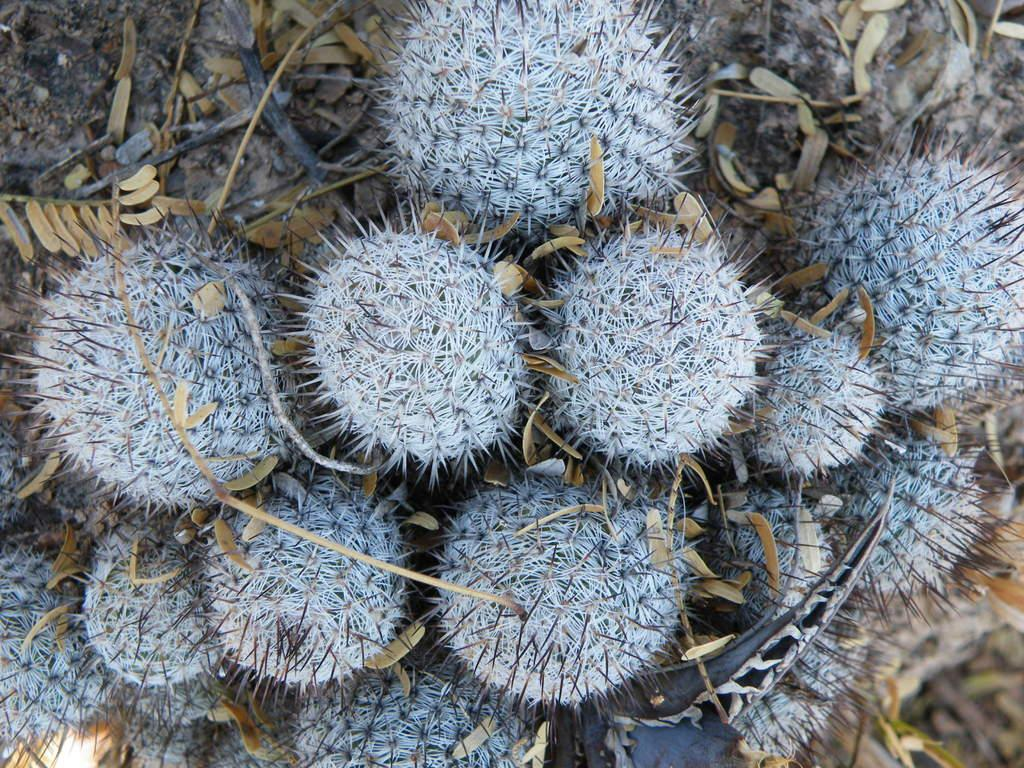What type of living organisms can be seen in the image? Plants can be seen in the image. What is a characteristic of the plants in the image? Dry leaves are present in the image. What part of the plants is visible in the image? Stems are visible in the image. How does the sock move around in the image? There is no sock present in the image. What type of sugar is visible in the image? There is no sugar present in the image. 